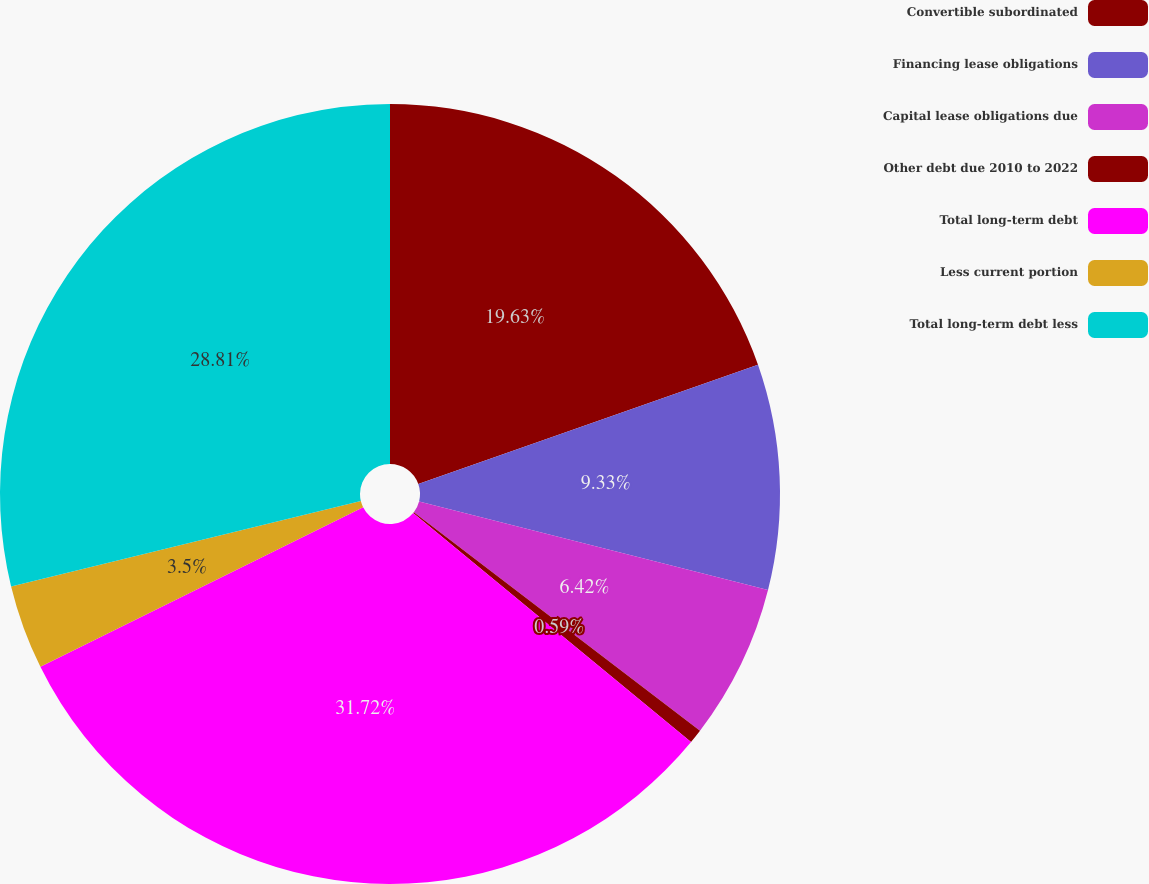Convert chart to OTSL. <chart><loc_0><loc_0><loc_500><loc_500><pie_chart><fcel>Convertible subordinated<fcel>Financing lease obligations<fcel>Capital lease obligations due<fcel>Other debt due 2010 to 2022<fcel>Total long-term debt<fcel>Less current portion<fcel>Total long-term debt less<nl><fcel>19.63%<fcel>9.33%<fcel>6.42%<fcel>0.59%<fcel>31.73%<fcel>3.5%<fcel>28.81%<nl></chart> 